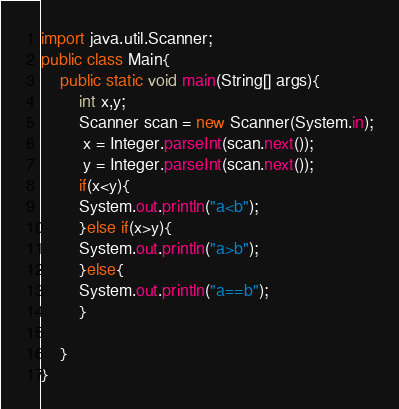Convert code to text. <code><loc_0><loc_0><loc_500><loc_500><_Java_>import java.util.Scanner;
public class Main{
	public static void main(String[] args){
		int x,y;
		Scanner scan = new Scanner(System.in);
	     x = Integer.parseInt(scan.next());
	     y = Integer.parseInt(scan.next());
		if(x<y){
		System.out.println("a<b");
		}else if(x>y){
		System.out.println("a>b");
		}else{
	    System.out.println("a==b");
		}
		
	}
}</code> 